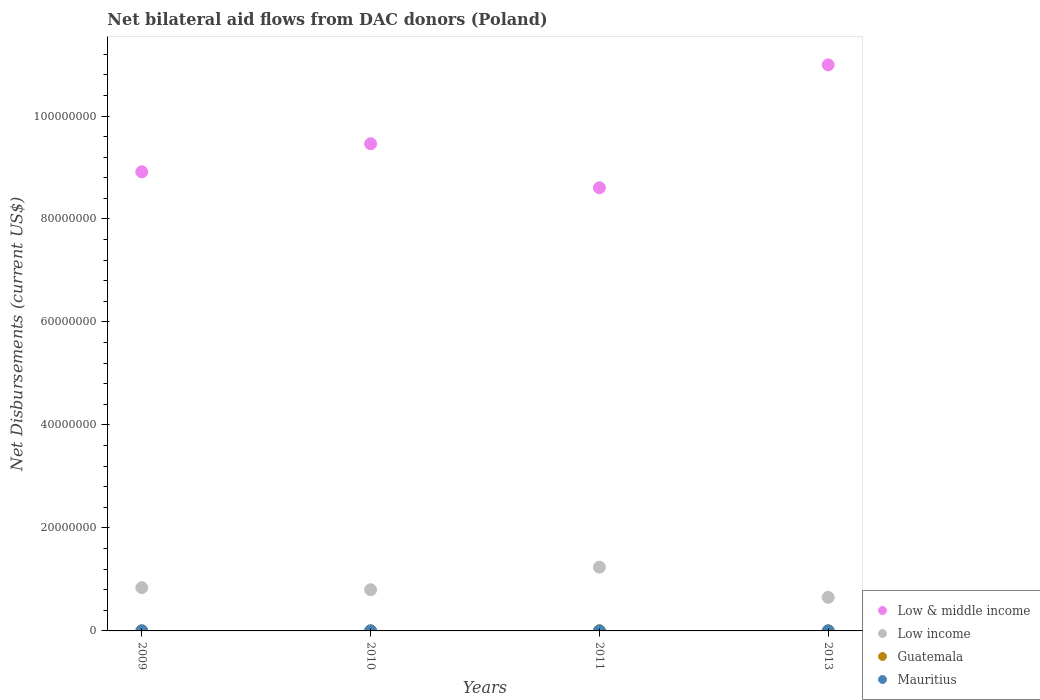What is the net bilateral aid flows in Guatemala in 2013?
Keep it short and to the point. 10000. Across all years, what is the maximum net bilateral aid flows in Low & middle income?
Give a very brief answer. 1.10e+08. Across all years, what is the minimum net bilateral aid flows in Low income?
Provide a succinct answer. 6.52e+06. In which year was the net bilateral aid flows in Low & middle income maximum?
Your answer should be very brief. 2013. What is the total net bilateral aid flows in Low & middle income in the graph?
Make the answer very short. 3.80e+08. What is the difference between the net bilateral aid flows in Low income in 2009 and that in 2010?
Your answer should be compact. 4.00e+05. What is the difference between the net bilateral aid flows in Low & middle income in 2013 and the net bilateral aid flows in Guatemala in 2010?
Provide a short and direct response. 1.10e+08. What is the average net bilateral aid flows in Mauritius per year?
Keep it short and to the point. 10000. In the year 2009, what is the difference between the net bilateral aid flows in Low & middle income and net bilateral aid flows in Low income?
Your answer should be very brief. 8.08e+07. What is the ratio of the net bilateral aid flows in Low income in 2010 to that in 2011?
Keep it short and to the point. 0.65. What is the difference between the highest and the second highest net bilateral aid flows in Mauritius?
Your answer should be compact. 0. What is the difference between the highest and the lowest net bilateral aid flows in Low income?
Give a very brief answer. 5.86e+06. In how many years, is the net bilateral aid flows in Guatemala greater than the average net bilateral aid flows in Guatemala taken over all years?
Provide a short and direct response. 1. Is it the case that in every year, the sum of the net bilateral aid flows in Low income and net bilateral aid flows in Mauritius  is greater than the sum of net bilateral aid flows in Low & middle income and net bilateral aid flows in Guatemala?
Provide a short and direct response. No. How many dotlines are there?
Make the answer very short. 4. How many years are there in the graph?
Ensure brevity in your answer.  4. Does the graph contain any zero values?
Provide a succinct answer. No. Where does the legend appear in the graph?
Give a very brief answer. Bottom right. How are the legend labels stacked?
Your response must be concise. Vertical. What is the title of the graph?
Provide a short and direct response. Net bilateral aid flows from DAC donors (Poland). Does "World" appear as one of the legend labels in the graph?
Your answer should be compact. No. What is the label or title of the Y-axis?
Give a very brief answer. Net Disbursements (current US$). What is the Net Disbursements (current US$) of Low & middle income in 2009?
Provide a short and direct response. 8.92e+07. What is the Net Disbursements (current US$) of Low income in 2009?
Offer a very short reply. 8.40e+06. What is the Net Disbursements (current US$) of Low & middle income in 2010?
Your answer should be compact. 9.46e+07. What is the Net Disbursements (current US$) in Mauritius in 2010?
Make the answer very short. 10000. What is the Net Disbursements (current US$) of Low & middle income in 2011?
Keep it short and to the point. 8.61e+07. What is the Net Disbursements (current US$) of Low income in 2011?
Your answer should be compact. 1.24e+07. What is the Net Disbursements (current US$) of Mauritius in 2011?
Offer a very short reply. 10000. What is the Net Disbursements (current US$) of Low & middle income in 2013?
Offer a terse response. 1.10e+08. What is the Net Disbursements (current US$) of Low income in 2013?
Offer a terse response. 6.52e+06. Across all years, what is the maximum Net Disbursements (current US$) in Low & middle income?
Your response must be concise. 1.10e+08. Across all years, what is the maximum Net Disbursements (current US$) of Low income?
Make the answer very short. 1.24e+07. Across all years, what is the maximum Net Disbursements (current US$) in Guatemala?
Your response must be concise. 2.00e+04. Across all years, what is the maximum Net Disbursements (current US$) of Mauritius?
Keep it short and to the point. 10000. Across all years, what is the minimum Net Disbursements (current US$) in Low & middle income?
Offer a terse response. 8.61e+07. Across all years, what is the minimum Net Disbursements (current US$) of Low income?
Give a very brief answer. 6.52e+06. What is the total Net Disbursements (current US$) in Low & middle income in the graph?
Give a very brief answer. 3.80e+08. What is the total Net Disbursements (current US$) in Low income in the graph?
Give a very brief answer. 3.53e+07. What is the total Net Disbursements (current US$) of Guatemala in the graph?
Your answer should be compact. 5.00e+04. What is the difference between the Net Disbursements (current US$) of Low & middle income in 2009 and that in 2010?
Ensure brevity in your answer.  -5.45e+06. What is the difference between the Net Disbursements (current US$) in Low income in 2009 and that in 2010?
Make the answer very short. 4.00e+05. What is the difference between the Net Disbursements (current US$) in Guatemala in 2009 and that in 2010?
Your answer should be very brief. 0. What is the difference between the Net Disbursements (current US$) in Low & middle income in 2009 and that in 2011?
Make the answer very short. 3.10e+06. What is the difference between the Net Disbursements (current US$) of Low income in 2009 and that in 2011?
Give a very brief answer. -3.98e+06. What is the difference between the Net Disbursements (current US$) in Guatemala in 2009 and that in 2011?
Provide a short and direct response. -10000. What is the difference between the Net Disbursements (current US$) of Low & middle income in 2009 and that in 2013?
Keep it short and to the point. -2.08e+07. What is the difference between the Net Disbursements (current US$) of Low income in 2009 and that in 2013?
Provide a short and direct response. 1.88e+06. What is the difference between the Net Disbursements (current US$) in Guatemala in 2009 and that in 2013?
Your answer should be very brief. 0. What is the difference between the Net Disbursements (current US$) of Mauritius in 2009 and that in 2013?
Your answer should be compact. 0. What is the difference between the Net Disbursements (current US$) of Low & middle income in 2010 and that in 2011?
Give a very brief answer. 8.55e+06. What is the difference between the Net Disbursements (current US$) in Low income in 2010 and that in 2011?
Give a very brief answer. -4.38e+06. What is the difference between the Net Disbursements (current US$) of Guatemala in 2010 and that in 2011?
Provide a succinct answer. -10000. What is the difference between the Net Disbursements (current US$) of Mauritius in 2010 and that in 2011?
Provide a succinct answer. 0. What is the difference between the Net Disbursements (current US$) of Low & middle income in 2010 and that in 2013?
Provide a short and direct response. -1.53e+07. What is the difference between the Net Disbursements (current US$) of Low income in 2010 and that in 2013?
Keep it short and to the point. 1.48e+06. What is the difference between the Net Disbursements (current US$) in Mauritius in 2010 and that in 2013?
Give a very brief answer. 0. What is the difference between the Net Disbursements (current US$) of Low & middle income in 2011 and that in 2013?
Provide a short and direct response. -2.39e+07. What is the difference between the Net Disbursements (current US$) of Low income in 2011 and that in 2013?
Give a very brief answer. 5.86e+06. What is the difference between the Net Disbursements (current US$) of Guatemala in 2011 and that in 2013?
Ensure brevity in your answer.  10000. What is the difference between the Net Disbursements (current US$) in Mauritius in 2011 and that in 2013?
Your answer should be compact. 0. What is the difference between the Net Disbursements (current US$) in Low & middle income in 2009 and the Net Disbursements (current US$) in Low income in 2010?
Make the answer very short. 8.12e+07. What is the difference between the Net Disbursements (current US$) in Low & middle income in 2009 and the Net Disbursements (current US$) in Guatemala in 2010?
Keep it short and to the point. 8.92e+07. What is the difference between the Net Disbursements (current US$) in Low & middle income in 2009 and the Net Disbursements (current US$) in Mauritius in 2010?
Give a very brief answer. 8.92e+07. What is the difference between the Net Disbursements (current US$) in Low income in 2009 and the Net Disbursements (current US$) in Guatemala in 2010?
Your answer should be compact. 8.39e+06. What is the difference between the Net Disbursements (current US$) in Low income in 2009 and the Net Disbursements (current US$) in Mauritius in 2010?
Ensure brevity in your answer.  8.39e+06. What is the difference between the Net Disbursements (current US$) in Guatemala in 2009 and the Net Disbursements (current US$) in Mauritius in 2010?
Make the answer very short. 0. What is the difference between the Net Disbursements (current US$) of Low & middle income in 2009 and the Net Disbursements (current US$) of Low income in 2011?
Your answer should be compact. 7.68e+07. What is the difference between the Net Disbursements (current US$) in Low & middle income in 2009 and the Net Disbursements (current US$) in Guatemala in 2011?
Make the answer very short. 8.91e+07. What is the difference between the Net Disbursements (current US$) of Low & middle income in 2009 and the Net Disbursements (current US$) of Mauritius in 2011?
Your answer should be compact. 8.92e+07. What is the difference between the Net Disbursements (current US$) in Low income in 2009 and the Net Disbursements (current US$) in Guatemala in 2011?
Provide a short and direct response. 8.38e+06. What is the difference between the Net Disbursements (current US$) in Low income in 2009 and the Net Disbursements (current US$) in Mauritius in 2011?
Offer a terse response. 8.39e+06. What is the difference between the Net Disbursements (current US$) of Guatemala in 2009 and the Net Disbursements (current US$) of Mauritius in 2011?
Your answer should be very brief. 0. What is the difference between the Net Disbursements (current US$) in Low & middle income in 2009 and the Net Disbursements (current US$) in Low income in 2013?
Offer a terse response. 8.26e+07. What is the difference between the Net Disbursements (current US$) in Low & middle income in 2009 and the Net Disbursements (current US$) in Guatemala in 2013?
Give a very brief answer. 8.92e+07. What is the difference between the Net Disbursements (current US$) of Low & middle income in 2009 and the Net Disbursements (current US$) of Mauritius in 2013?
Offer a terse response. 8.92e+07. What is the difference between the Net Disbursements (current US$) in Low income in 2009 and the Net Disbursements (current US$) in Guatemala in 2013?
Keep it short and to the point. 8.39e+06. What is the difference between the Net Disbursements (current US$) of Low income in 2009 and the Net Disbursements (current US$) of Mauritius in 2013?
Offer a terse response. 8.39e+06. What is the difference between the Net Disbursements (current US$) of Low & middle income in 2010 and the Net Disbursements (current US$) of Low income in 2011?
Offer a very short reply. 8.22e+07. What is the difference between the Net Disbursements (current US$) of Low & middle income in 2010 and the Net Disbursements (current US$) of Guatemala in 2011?
Your response must be concise. 9.46e+07. What is the difference between the Net Disbursements (current US$) of Low & middle income in 2010 and the Net Disbursements (current US$) of Mauritius in 2011?
Ensure brevity in your answer.  9.46e+07. What is the difference between the Net Disbursements (current US$) in Low income in 2010 and the Net Disbursements (current US$) in Guatemala in 2011?
Offer a terse response. 7.98e+06. What is the difference between the Net Disbursements (current US$) in Low income in 2010 and the Net Disbursements (current US$) in Mauritius in 2011?
Give a very brief answer. 7.99e+06. What is the difference between the Net Disbursements (current US$) in Low & middle income in 2010 and the Net Disbursements (current US$) in Low income in 2013?
Provide a short and direct response. 8.81e+07. What is the difference between the Net Disbursements (current US$) of Low & middle income in 2010 and the Net Disbursements (current US$) of Guatemala in 2013?
Ensure brevity in your answer.  9.46e+07. What is the difference between the Net Disbursements (current US$) of Low & middle income in 2010 and the Net Disbursements (current US$) of Mauritius in 2013?
Ensure brevity in your answer.  9.46e+07. What is the difference between the Net Disbursements (current US$) in Low income in 2010 and the Net Disbursements (current US$) in Guatemala in 2013?
Offer a very short reply. 7.99e+06. What is the difference between the Net Disbursements (current US$) of Low income in 2010 and the Net Disbursements (current US$) of Mauritius in 2013?
Your answer should be compact. 7.99e+06. What is the difference between the Net Disbursements (current US$) of Guatemala in 2010 and the Net Disbursements (current US$) of Mauritius in 2013?
Offer a terse response. 0. What is the difference between the Net Disbursements (current US$) of Low & middle income in 2011 and the Net Disbursements (current US$) of Low income in 2013?
Provide a short and direct response. 7.95e+07. What is the difference between the Net Disbursements (current US$) of Low & middle income in 2011 and the Net Disbursements (current US$) of Guatemala in 2013?
Give a very brief answer. 8.60e+07. What is the difference between the Net Disbursements (current US$) of Low & middle income in 2011 and the Net Disbursements (current US$) of Mauritius in 2013?
Ensure brevity in your answer.  8.60e+07. What is the difference between the Net Disbursements (current US$) of Low income in 2011 and the Net Disbursements (current US$) of Guatemala in 2013?
Make the answer very short. 1.24e+07. What is the difference between the Net Disbursements (current US$) in Low income in 2011 and the Net Disbursements (current US$) in Mauritius in 2013?
Provide a succinct answer. 1.24e+07. What is the difference between the Net Disbursements (current US$) in Guatemala in 2011 and the Net Disbursements (current US$) in Mauritius in 2013?
Keep it short and to the point. 10000. What is the average Net Disbursements (current US$) of Low & middle income per year?
Keep it short and to the point. 9.49e+07. What is the average Net Disbursements (current US$) in Low income per year?
Your answer should be very brief. 8.82e+06. What is the average Net Disbursements (current US$) of Guatemala per year?
Your answer should be compact. 1.25e+04. In the year 2009, what is the difference between the Net Disbursements (current US$) in Low & middle income and Net Disbursements (current US$) in Low income?
Give a very brief answer. 8.08e+07. In the year 2009, what is the difference between the Net Disbursements (current US$) in Low & middle income and Net Disbursements (current US$) in Guatemala?
Provide a short and direct response. 8.92e+07. In the year 2009, what is the difference between the Net Disbursements (current US$) of Low & middle income and Net Disbursements (current US$) of Mauritius?
Your answer should be very brief. 8.92e+07. In the year 2009, what is the difference between the Net Disbursements (current US$) in Low income and Net Disbursements (current US$) in Guatemala?
Offer a terse response. 8.39e+06. In the year 2009, what is the difference between the Net Disbursements (current US$) of Low income and Net Disbursements (current US$) of Mauritius?
Offer a very short reply. 8.39e+06. In the year 2009, what is the difference between the Net Disbursements (current US$) of Guatemala and Net Disbursements (current US$) of Mauritius?
Provide a short and direct response. 0. In the year 2010, what is the difference between the Net Disbursements (current US$) of Low & middle income and Net Disbursements (current US$) of Low income?
Your answer should be very brief. 8.66e+07. In the year 2010, what is the difference between the Net Disbursements (current US$) of Low & middle income and Net Disbursements (current US$) of Guatemala?
Keep it short and to the point. 9.46e+07. In the year 2010, what is the difference between the Net Disbursements (current US$) of Low & middle income and Net Disbursements (current US$) of Mauritius?
Your response must be concise. 9.46e+07. In the year 2010, what is the difference between the Net Disbursements (current US$) of Low income and Net Disbursements (current US$) of Guatemala?
Make the answer very short. 7.99e+06. In the year 2010, what is the difference between the Net Disbursements (current US$) of Low income and Net Disbursements (current US$) of Mauritius?
Your answer should be compact. 7.99e+06. In the year 2011, what is the difference between the Net Disbursements (current US$) of Low & middle income and Net Disbursements (current US$) of Low income?
Provide a succinct answer. 7.37e+07. In the year 2011, what is the difference between the Net Disbursements (current US$) in Low & middle income and Net Disbursements (current US$) in Guatemala?
Keep it short and to the point. 8.60e+07. In the year 2011, what is the difference between the Net Disbursements (current US$) of Low & middle income and Net Disbursements (current US$) of Mauritius?
Offer a terse response. 8.60e+07. In the year 2011, what is the difference between the Net Disbursements (current US$) in Low income and Net Disbursements (current US$) in Guatemala?
Offer a terse response. 1.24e+07. In the year 2011, what is the difference between the Net Disbursements (current US$) of Low income and Net Disbursements (current US$) of Mauritius?
Give a very brief answer. 1.24e+07. In the year 2013, what is the difference between the Net Disbursements (current US$) in Low & middle income and Net Disbursements (current US$) in Low income?
Your answer should be compact. 1.03e+08. In the year 2013, what is the difference between the Net Disbursements (current US$) in Low & middle income and Net Disbursements (current US$) in Guatemala?
Keep it short and to the point. 1.10e+08. In the year 2013, what is the difference between the Net Disbursements (current US$) of Low & middle income and Net Disbursements (current US$) of Mauritius?
Offer a very short reply. 1.10e+08. In the year 2013, what is the difference between the Net Disbursements (current US$) of Low income and Net Disbursements (current US$) of Guatemala?
Keep it short and to the point. 6.51e+06. In the year 2013, what is the difference between the Net Disbursements (current US$) in Low income and Net Disbursements (current US$) in Mauritius?
Offer a very short reply. 6.51e+06. In the year 2013, what is the difference between the Net Disbursements (current US$) in Guatemala and Net Disbursements (current US$) in Mauritius?
Your answer should be very brief. 0. What is the ratio of the Net Disbursements (current US$) of Low & middle income in 2009 to that in 2010?
Make the answer very short. 0.94. What is the ratio of the Net Disbursements (current US$) in Mauritius in 2009 to that in 2010?
Ensure brevity in your answer.  1. What is the ratio of the Net Disbursements (current US$) in Low & middle income in 2009 to that in 2011?
Offer a very short reply. 1.04. What is the ratio of the Net Disbursements (current US$) of Low income in 2009 to that in 2011?
Your answer should be very brief. 0.68. What is the ratio of the Net Disbursements (current US$) in Low & middle income in 2009 to that in 2013?
Your answer should be compact. 0.81. What is the ratio of the Net Disbursements (current US$) of Low income in 2009 to that in 2013?
Ensure brevity in your answer.  1.29. What is the ratio of the Net Disbursements (current US$) in Low & middle income in 2010 to that in 2011?
Your response must be concise. 1.1. What is the ratio of the Net Disbursements (current US$) in Low income in 2010 to that in 2011?
Offer a very short reply. 0.65. What is the ratio of the Net Disbursements (current US$) in Low & middle income in 2010 to that in 2013?
Ensure brevity in your answer.  0.86. What is the ratio of the Net Disbursements (current US$) of Low income in 2010 to that in 2013?
Ensure brevity in your answer.  1.23. What is the ratio of the Net Disbursements (current US$) in Guatemala in 2010 to that in 2013?
Your response must be concise. 1. What is the ratio of the Net Disbursements (current US$) of Mauritius in 2010 to that in 2013?
Give a very brief answer. 1. What is the ratio of the Net Disbursements (current US$) of Low & middle income in 2011 to that in 2013?
Ensure brevity in your answer.  0.78. What is the ratio of the Net Disbursements (current US$) of Low income in 2011 to that in 2013?
Offer a terse response. 1.9. What is the ratio of the Net Disbursements (current US$) of Guatemala in 2011 to that in 2013?
Offer a very short reply. 2. What is the difference between the highest and the second highest Net Disbursements (current US$) of Low & middle income?
Ensure brevity in your answer.  1.53e+07. What is the difference between the highest and the second highest Net Disbursements (current US$) of Low income?
Your answer should be compact. 3.98e+06. What is the difference between the highest and the second highest Net Disbursements (current US$) of Mauritius?
Your answer should be very brief. 0. What is the difference between the highest and the lowest Net Disbursements (current US$) of Low & middle income?
Keep it short and to the point. 2.39e+07. What is the difference between the highest and the lowest Net Disbursements (current US$) of Low income?
Give a very brief answer. 5.86e+06. What is the difference between the highest and the lowest Net Disbursements (current US$) of Guatemala?
Your answer should be very brief. 10000. 